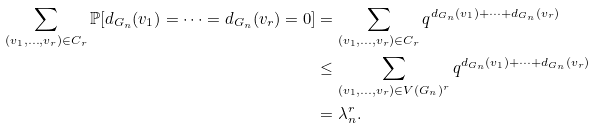<formula> <loc_0><loc_0><loc_500><loc_500>\sum _ { ( v _ { 1 } , \dots , v _ { r } ) \in C _ { r } } \mathbb { P } [ d _ { G _ { n } } ( v _ { 1 } ) = \dots = d _ { G _ { n } } ( v _ { r } ) = 0 ] & = \sum _ { ( v _ { 1 } , \dots , v _ { r } ) \in C _ { r } } q ^ { d _ { G _ { n } } ( v _ { 1 } ) + \dots + d _ { G _ { n } } ( v _ { r } ) } \\ & \leq \sum _ { ( v _ { 1 } , \dots , v _ { r } ) \in V ( G _ { n } ) ^ { r } } q ^ { d _ { G _ { n } } ( v _ { 1 } ) + \dots + d _ { G _ { n } } ( v _ { r } ) } \\ & = \lambda _ { n } ^ { r } .</formula> 